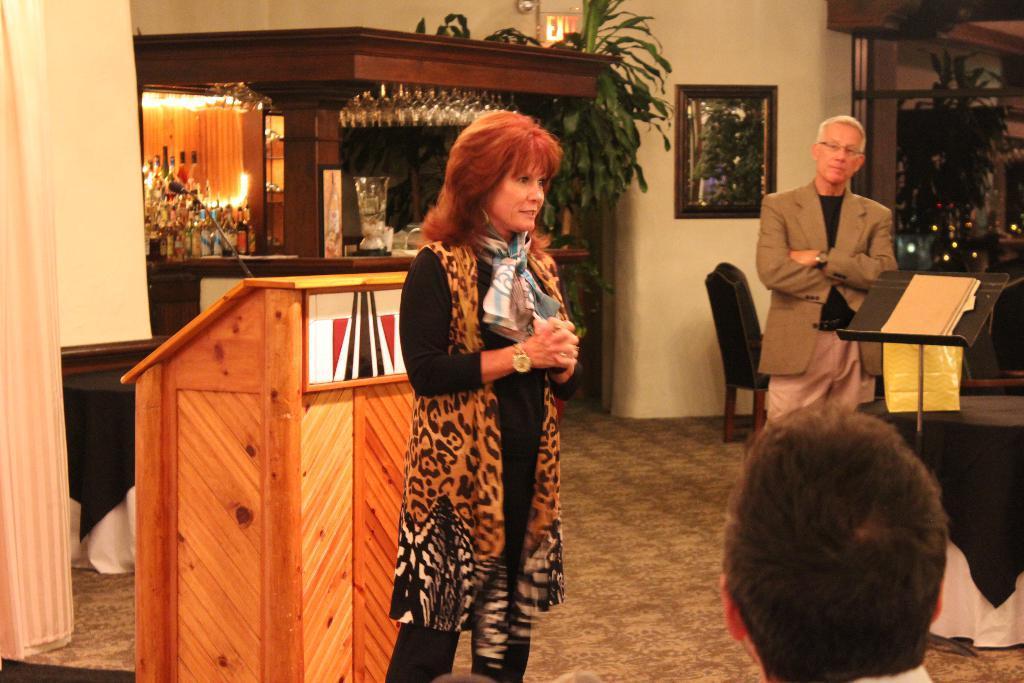In one or two sentences, can you explain what this image depicts? In this image there is a woman standing before the podium. On the podium there is a mike. Behind it there is a cabin having few bottles kept on the shelf. Few glasses are hanged from the roof of a cabin. Beside the cabin there is a plant. Right side there is a person wearing a suit is standing behind the stand having a book on it. Bottom of the image there is a person. Right side there is a table covered with a cloth. A chair is kept near the wall having a picture frame attached to the wall. Right side there is a window. Behind it there is a planet visible. Left side there is a curtain. There are few clothes kept on the floor. 